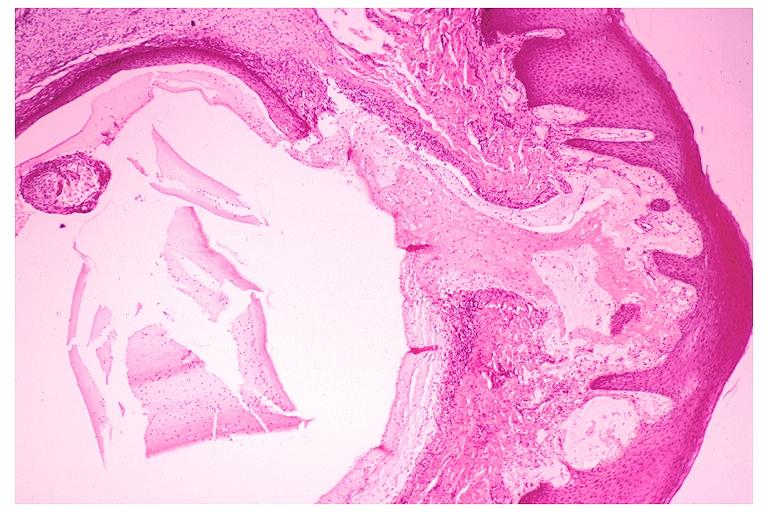what is present?
Answer the question using a single word or phrase. Oral 